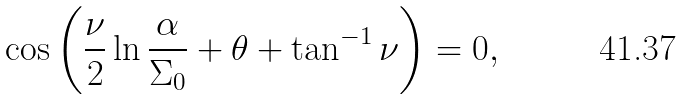<formula> <loc_0><loc_0><loc_500><loc_500>\cos \left ( \frac { \nu } { 2 } \ln \frac { \alpha } { \Sigma _ { 0 } } + \theta + \tan ^ { - 1 } \nu \right ) = 0 ,</formula> 